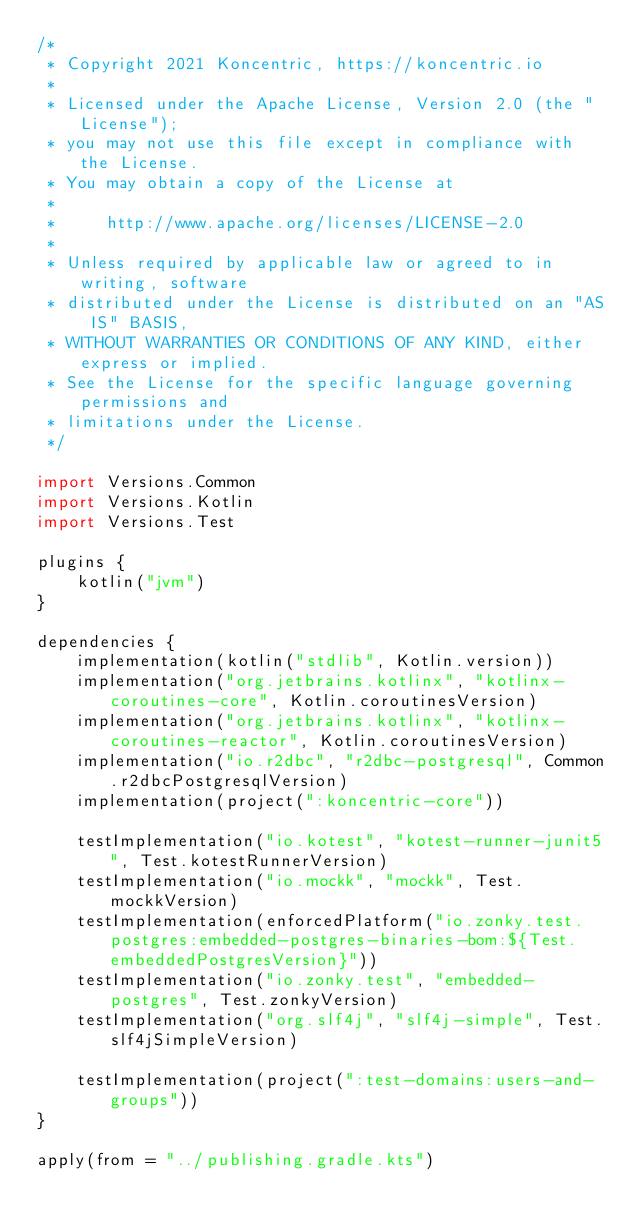Convert code to text. <code><loc_0><loc_0><loc_500><loc_500><_Kotlin_>/*
 * Copyright 2021 Koncentric, https://koncentric.io
 *
 * Licensed under the Apache License, Version 2.0 (the "License");
 * you may not use this file except in compliance with the License.
 * You may obtain a copy of the License at
 *
 *     http://www.apache.org/licenses/LICENSE-2.0
 *
 * Unless required by applicable law or agreed to in writing, software
 * distributed under the License is distributed on an "AS IS" BASIS,
 * WITHOUT WARRANTIES OR CONDITIONS OF ANY KIND, either express or implied.
 * See the License for the specific language governing permissions and
 * limitations under the License.
 */

import Versions.Common
import Versions.Kotlin
import Versions.Test

plugins {
    kotlin("jvm")
}

dependencies {
    implementation(kotlin("stdlib", Kotlin.version))
    implementation("org.jetbrains.kotlinx", "kotlinx-coroutines-core", Kotlin.coroutinesVersion)
    implementation("org.jetbrains.kotlinx", "kotlinx-coroutines-reactor", Kotlin.coroutinesVersion)
    implementation("io.r2dbc", "r2dbc-postgresql", Common.r2dbcPostgresqlVersion)
    implementation(project(":koncentric-core"))

    testImplementation("io.kotest", "kotest-runner-junit5", Test.kotestRunnerVersion)
    testImplementation("io.mockk", "mockk", Test.mockkVersion)
    testImplementation(enforcedPlatform("io.zonky.test.postgres:embedded-postgres-binaries-bom:${Test.embeddedPostgresVersion}"))
    testImplementation("io.zonky.test", "embedded-postgres", Test.zonkyVersion)
    testImplementation("org.slf4j", "slf4j-simple", Test.slf4jSimpleVersion)

    testImplementation(project(":test-domains:users-and-groups"))
}

apply(from = "../publishing.gradle.kts")</code> 